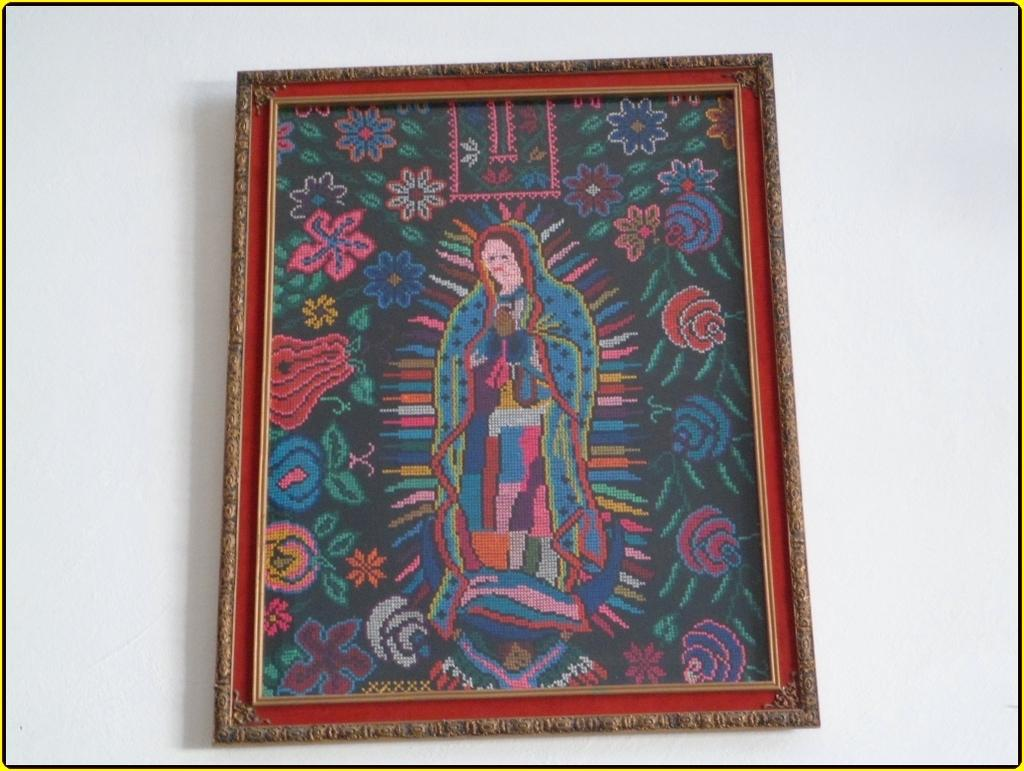What is on the wall in the image? There is a frame on the wall in the image. How many houses are depicted in the frame on the wall? There is no information about the content of the frame in the image, so it is impossible to determine if any houses are depicted. 